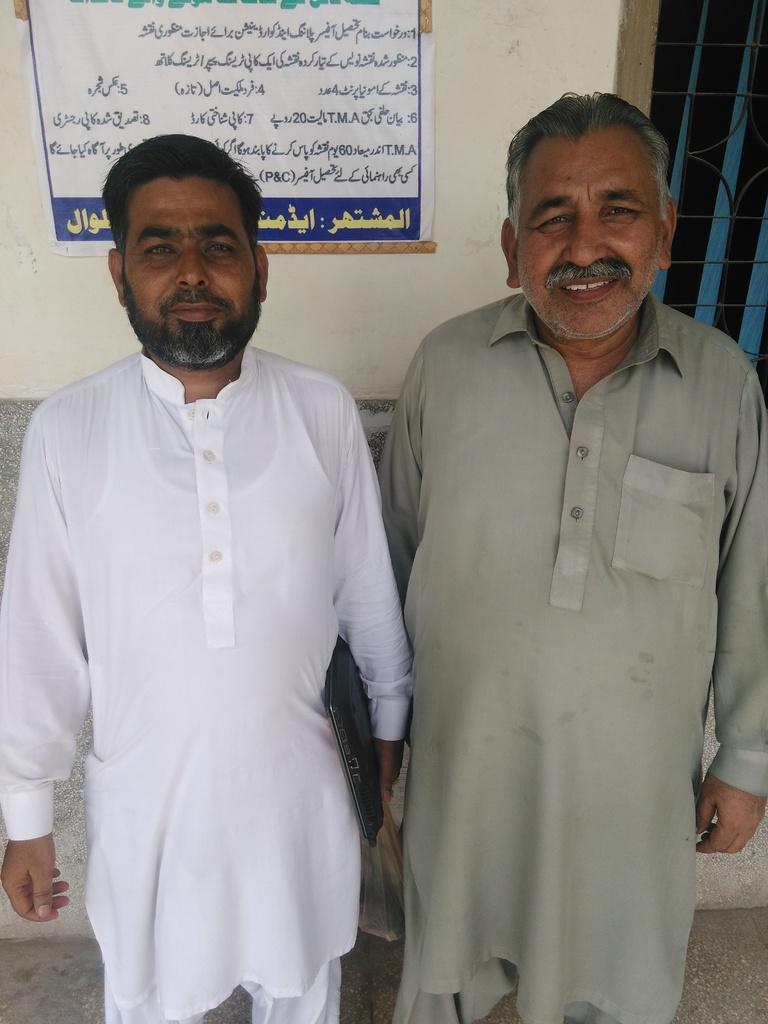Could you give a brief overview of what you see in this image? In this image there are two men standing together in room, behind them there is a wall with some banner on it. 